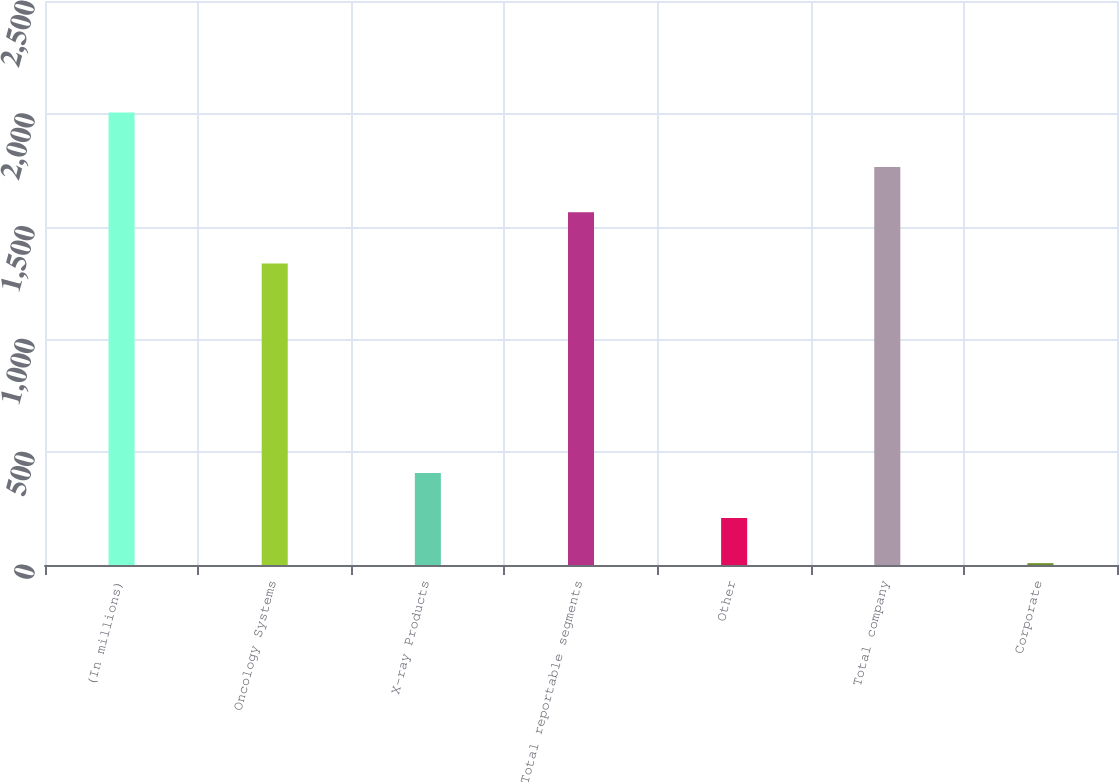Convert chart. <chart><loc_0><loc_0><loc_500><loc_500><bar_chart><fcel>(In millions)<fcel>Oncology Systems<fcel>X-ray Products<fcel>Total reportable segments<fcel>Other<fcel>Total company<fcel>Corporate<nl><fcel>2006<fcel>1336<fcel>407.6<fcel>1564<fcel>207.8<fcel>1763.8<fcel>8<nl></chart> 